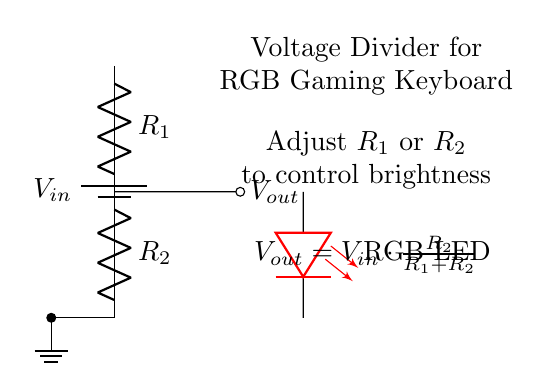What is the input voltage of this circuit? The input voltage, noted as V_in, is indicated on the battery symbol at the top of the circuit. It represents the source voltage provided to the voltage divider.
Answer: V_in What resistors are used in the voltage divider? The circuit shows two resistors labeled R_1 and R_2, which are the components that create the voltage division as they are connected in series.
Answer: R_1 and R_2 What is the formula for output voltage? The formula for output voltage is provided in the annotations of the circuit: V_out equals V_in multiplied by R_2 divided by the sum of R_1 and R_2.
Answer: V_out = V_in * (R_2 / (R_1 + R_2)) How does changing R_1 affect LED brightness? Decreasing R_1 lowers its resistance, which increases the output voltage V_out according to the voltage divider formula, thereby making the LED brighter.
Answer: Increases brightness What is the purpose of the RGB LED in this circuit? The RGB LED is used as an indicator of the output voltage, which is affected by the voltage divider, thus visually demonstrating the effect of adjusting R_1 and R_2 on brightness.
Answer: To indicate brightness What happens if R_2 is increased? Increasing R_2 raises its resistance, causing a higher V_out according to the voltage divider equation, resulting in a brighter LED because more voltage is available across it.
Answer: Increases brightness 